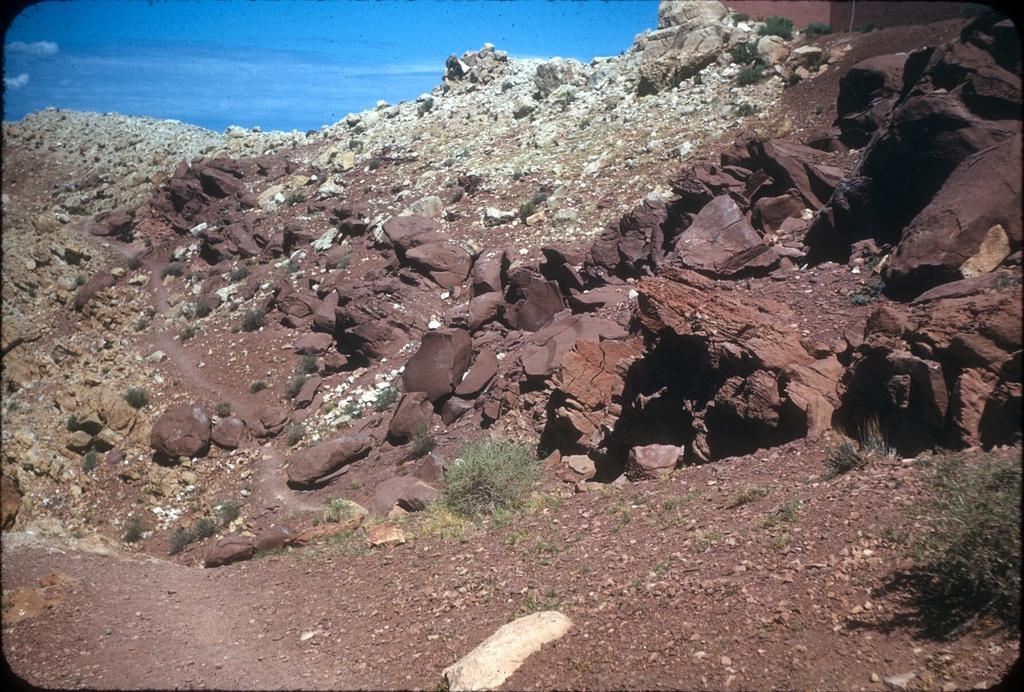What is the primary element in the image? There is water in the image. What other natural elements can be seen in the image? There are stones, rocks, and shrubs visible in the image. What is the ground like in the image? The ground is visible in the image. What type of card is being used to play a game in the image? There is no card present in the image; it features water, stones, rocks, shrubs, and visible ground. 